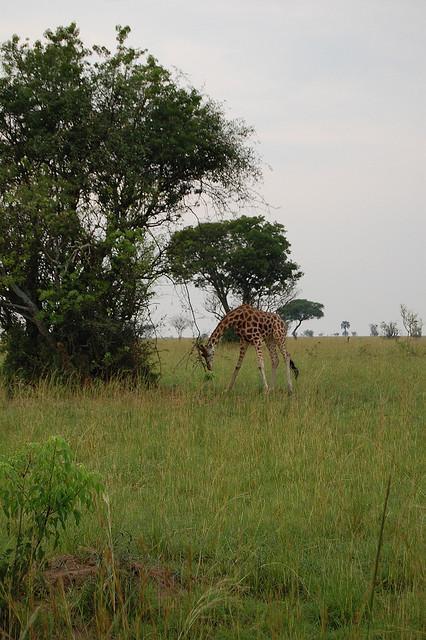How many animals can be seen?
Give a very brief answer. 1. 